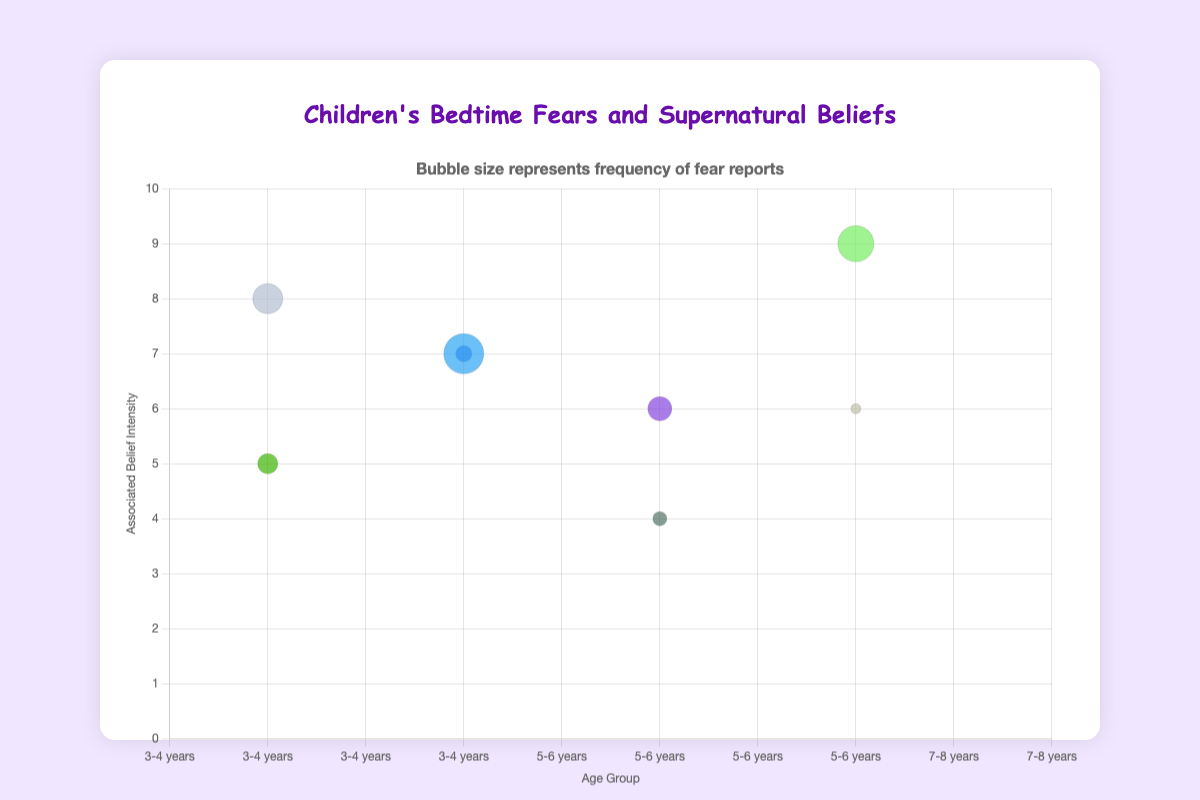What is the title of the chart? The title of the chart is written above the bubble chart in the designated title section.
Answer: Children's Bedtime Fears and Supernatural Beliefs What are the axes labels? By looking at the text aligned along the horizontal and vertical axes of the chart, we can see the labels.
Answer: Age Group (x-axis), Associated Belief Intensity (y-axis) Which age group reports the highest frequency of fears? By comparing the sizes of the bubbles within the different age groups, we can determine which has the largest bubble. The age group '3-4 years' has the biggest bubble for 'Darkness' with a frequency of 20, indicating it reports the highest frequency of fears.
Answer: 3-4 years Which fear has the highest associated belief intensity? By looking at the vertical positioning of the bubbles, we can see which is positioned the highest on the y-axis. The bubble for "Closet monsters" in the 5-6 years group has the maximum associated belief intensity of 9.
Answer: Closet monsters What is the relationship between being alone in the dark and its associated supernatural belief? Looking at the tooltip information for 'Being alone in the dark', we can see both the fear and the associated supernatural belief. The associated supernatural belief is 'Shadow people' with a belief intensity of 5.
Answer: Shadow people, intensity 5 How many types of fears are reported for the 7-8 years age group? By counting the number of unique bubbles located within the '7-8 years' age group on the x-axis, we determine there are two types of fears: 'Being alone in the dark' and 'Mirror reflections'.
Answer: 2 Which type of fear in the 3-4 years age group is associated with the 'Boogeyman'? By identifying the bubble labels within the 3-4 years age group and checking their associated supernatural beliefs, we find that 'Monsters under the bed' is associated with the 'Boogeyman'.
Answer: Monsters under the bed What is the number of fear reports for 'Strange noises'? By looking at the bubble for 'Strange noises', the tooltip reveals it has a frequency of fear reports of 12.
Answer: 12 Compare the frequency of fear reports for 'Monsters under the bed' and 'Closet monsters'. Which one is higher? By comparing the size of the bubbles for 'Monsters under the bed' (15) and 'Closet monsters' (18), we see that 'Closet monsters' has a higher frequency of fear reports.
Answer: Closet monsters What is the combined belief intensity of fears related to 'Ghosts'? Locate the bubbles associated with 'Ghosts' and sum their belief intensities. 'Darkness' (7) in 3-4 years and 'Attic sounds' (4) in 9-10 years make the combined belief intensity 7 + 4 = 11.
Answer: 11 